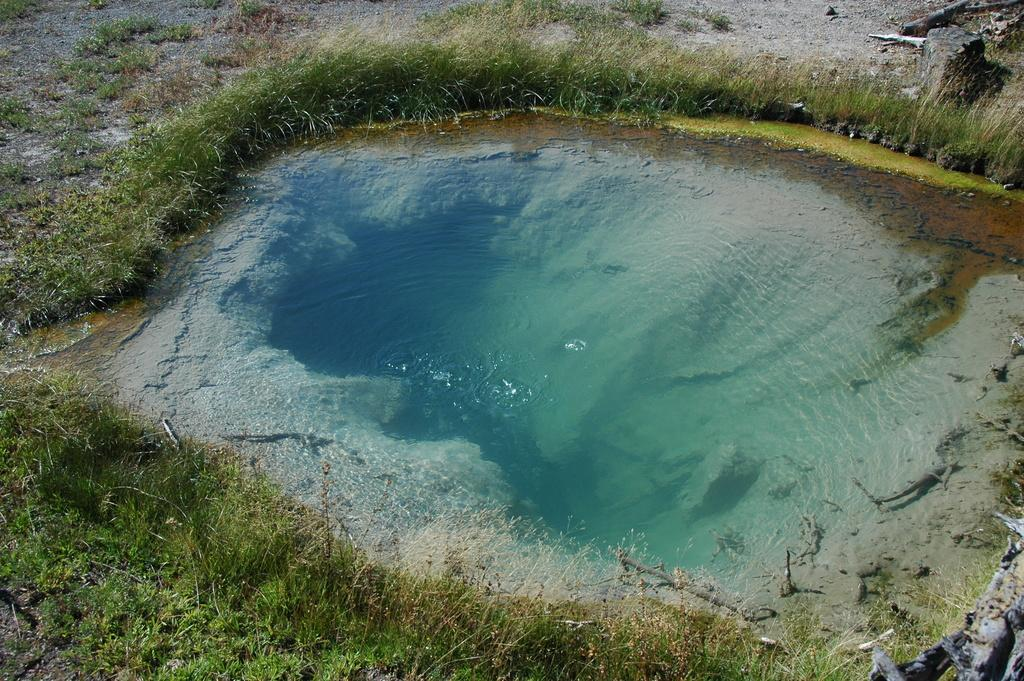What is visible in the image? There is water visible in the image. What is located near the water? There is a group of plants around the water. Can you describe any other objects in the image? There is a rock in the top right of the image. What type of writing can be seen on the rock in the image? There is no writing visible on the rock in the image. Is there a glove present in the image? There is no glove present in the image. 